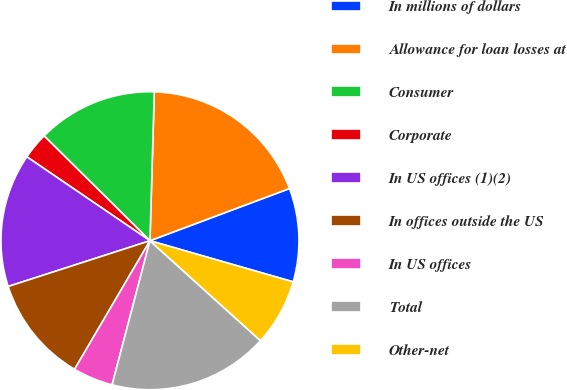Convert chart to OTSL. <chart><loc_0><loc_0><loc_500><loc_500><pie_chart><fcel>In millions of dollars<fcel>Allowance for loan losses at<fcel>Consumer<fcel>Corporate<fcel>In US offices (1)(2)<fcel>In offices outside the US<fcel>In US offices<fcel>Total<fcel>Other-net<nl><fcel>10.15%<fcel>18.84%<fcel>13.04%<fcel>2.9%<fcel>14.49%<fcel>11.59%<fcel>4.35%<fcel>17.39%<fcel>7.25%<nl></chart> 